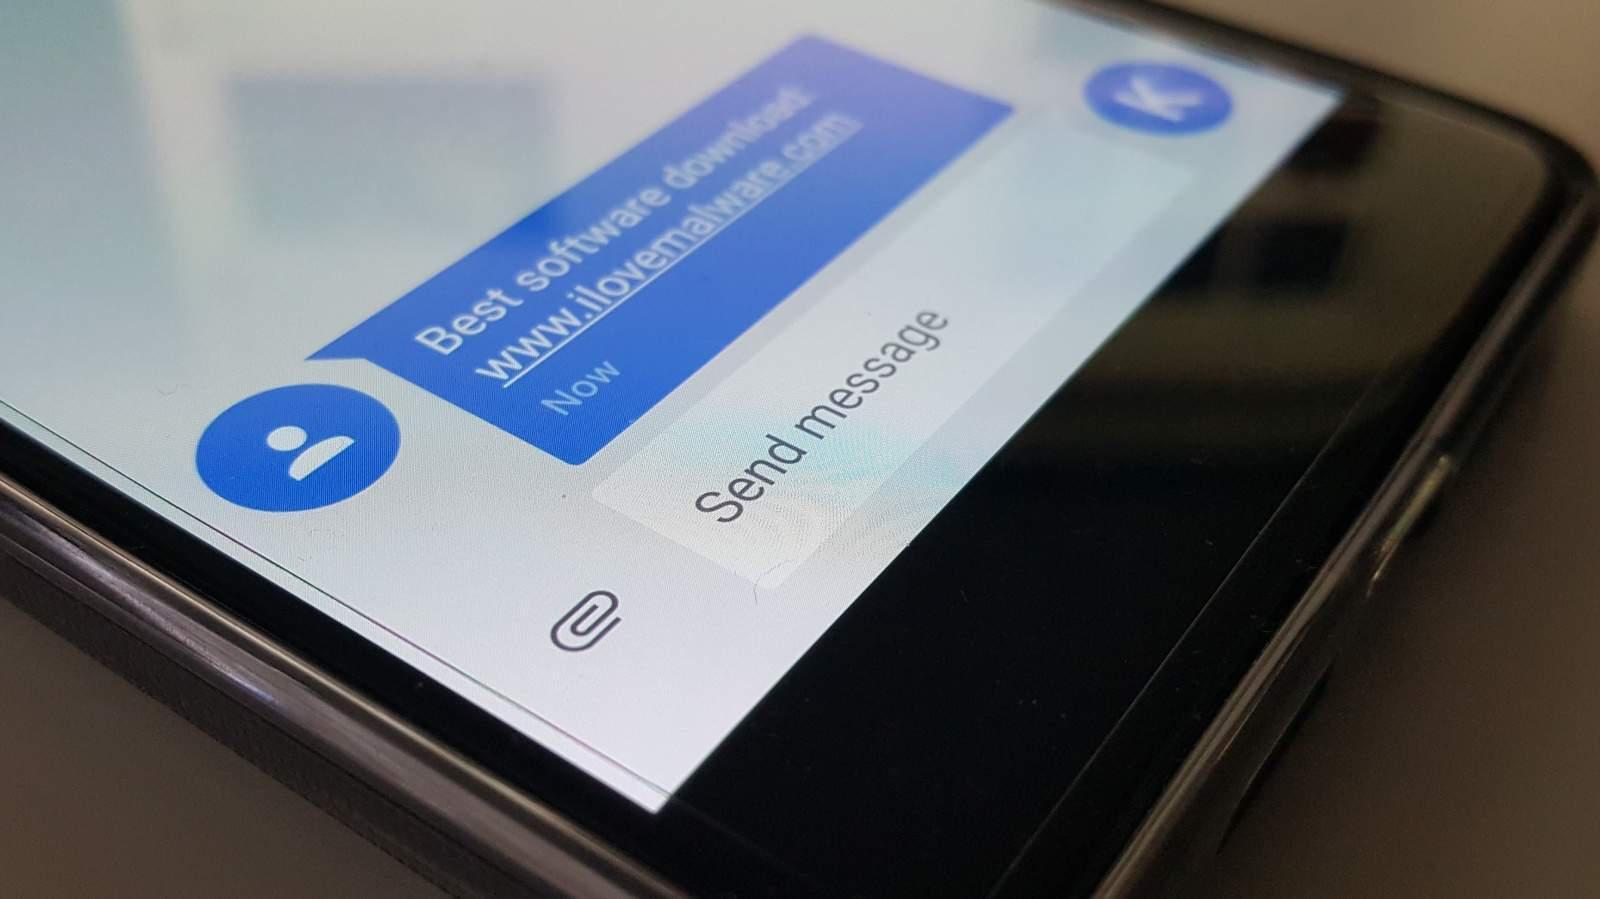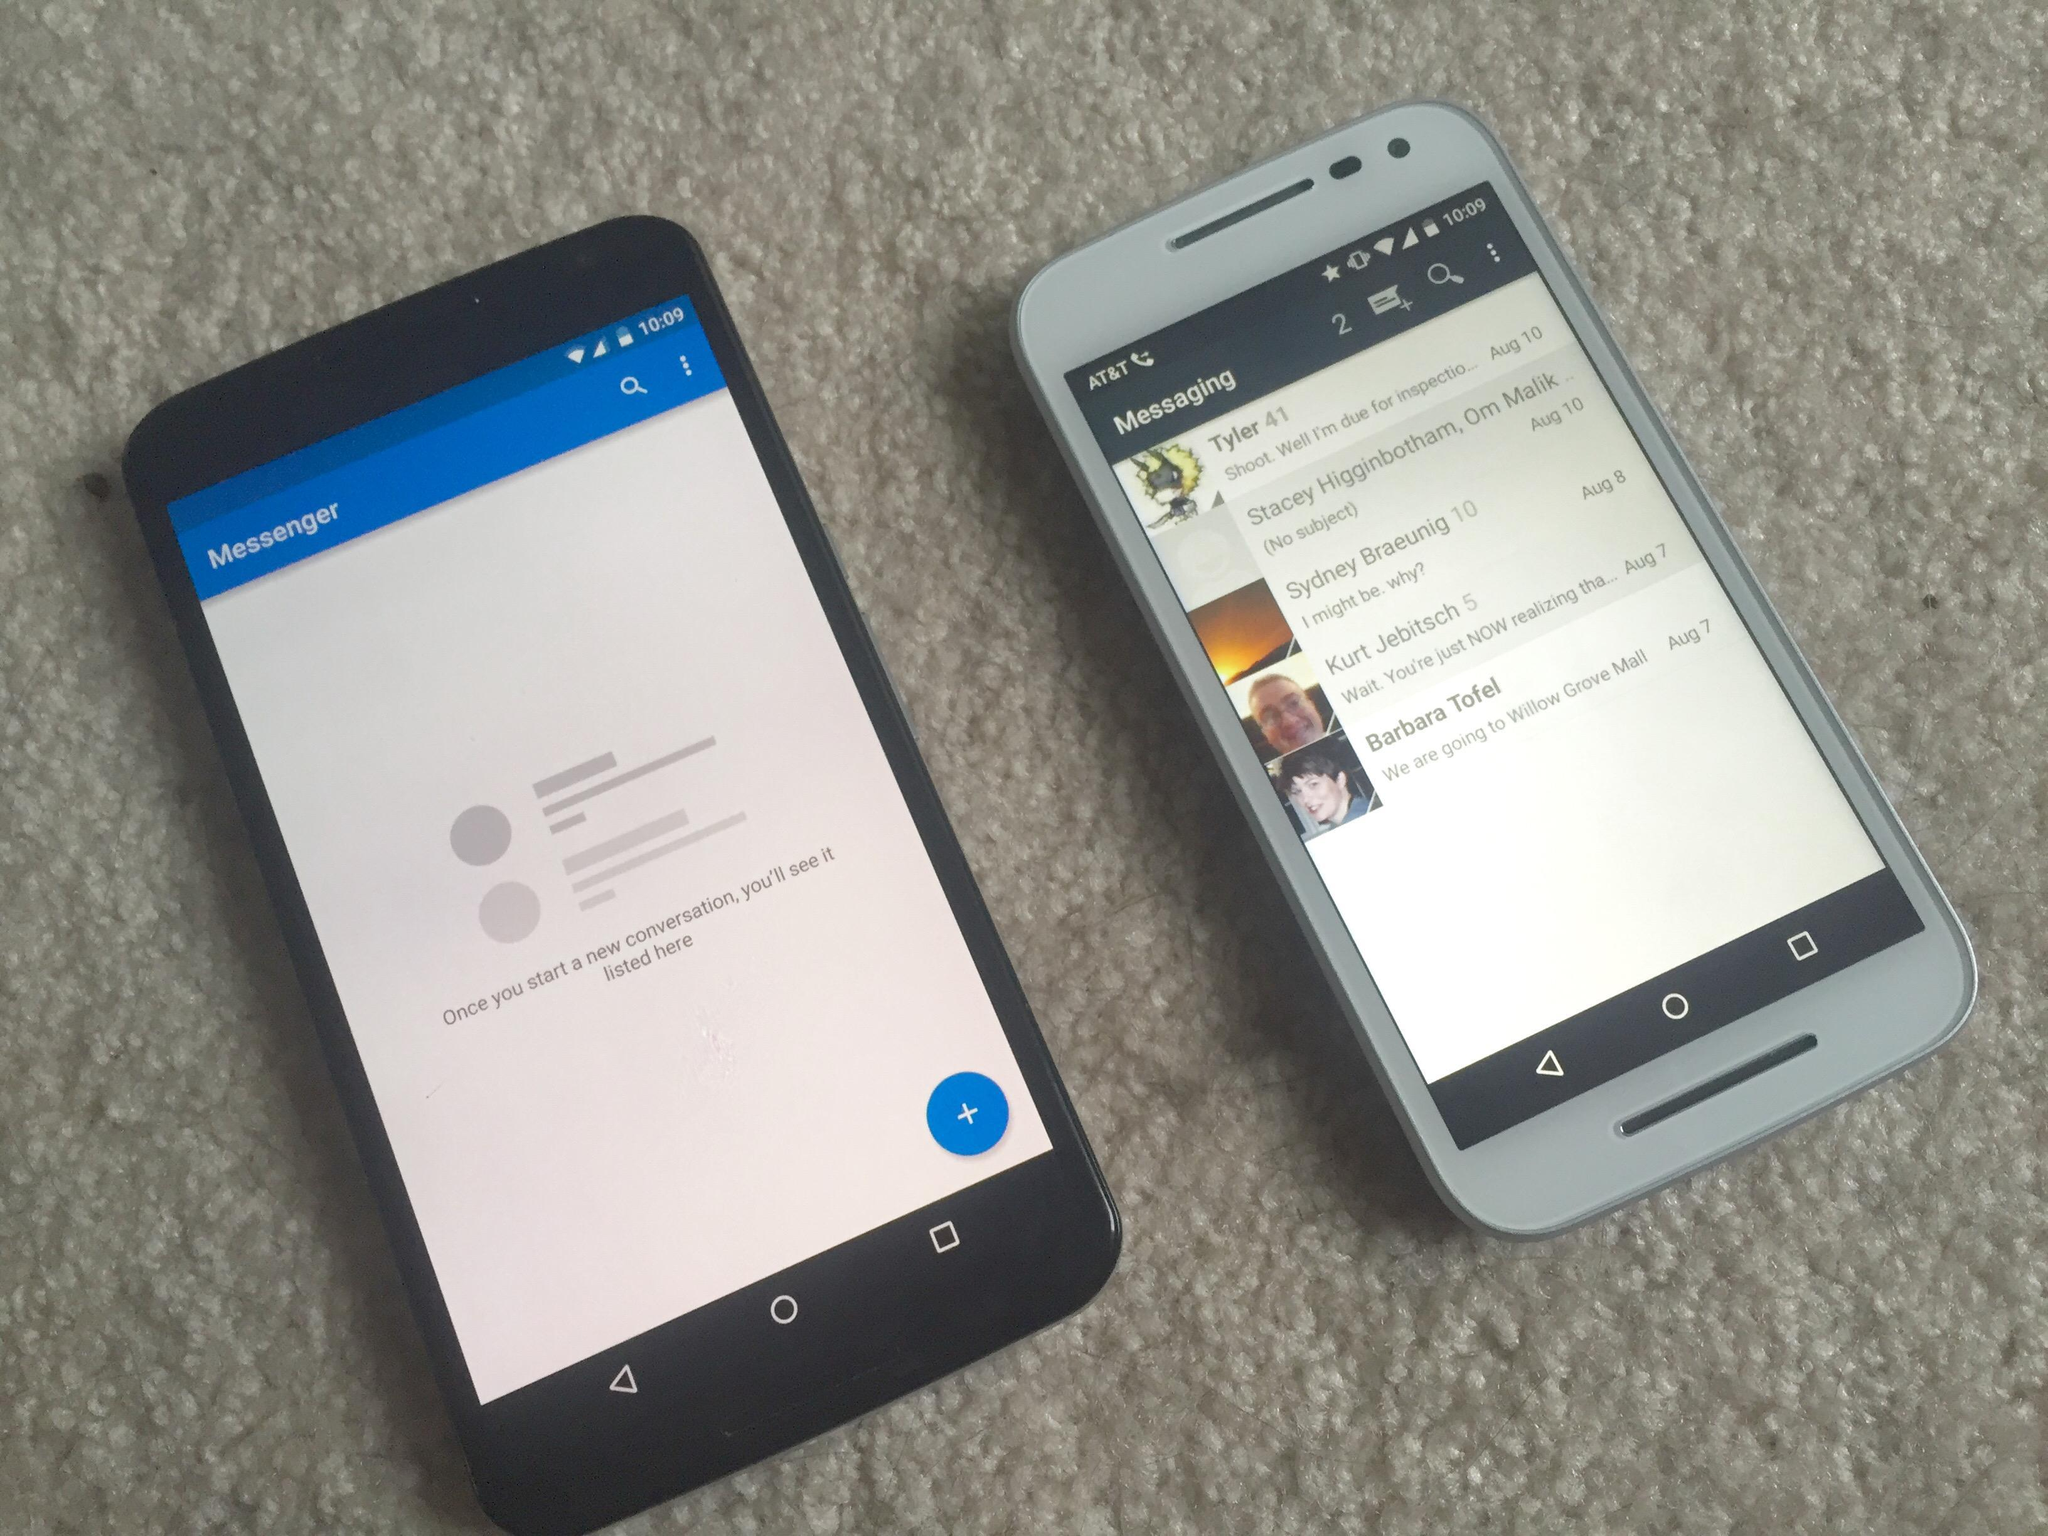The first image is the image on the left, the second image is the image on the right. For the images shown, is this caption "A thumb is pressing the phone's screen in the image on the left." true? Answer yes or no. No. The first image is the image on the left, the second image is the image on the right. Examine the images to the left and right. Is the description "A person is holding the phone in at least one of the images." accurate? Answer yes or no. No. 